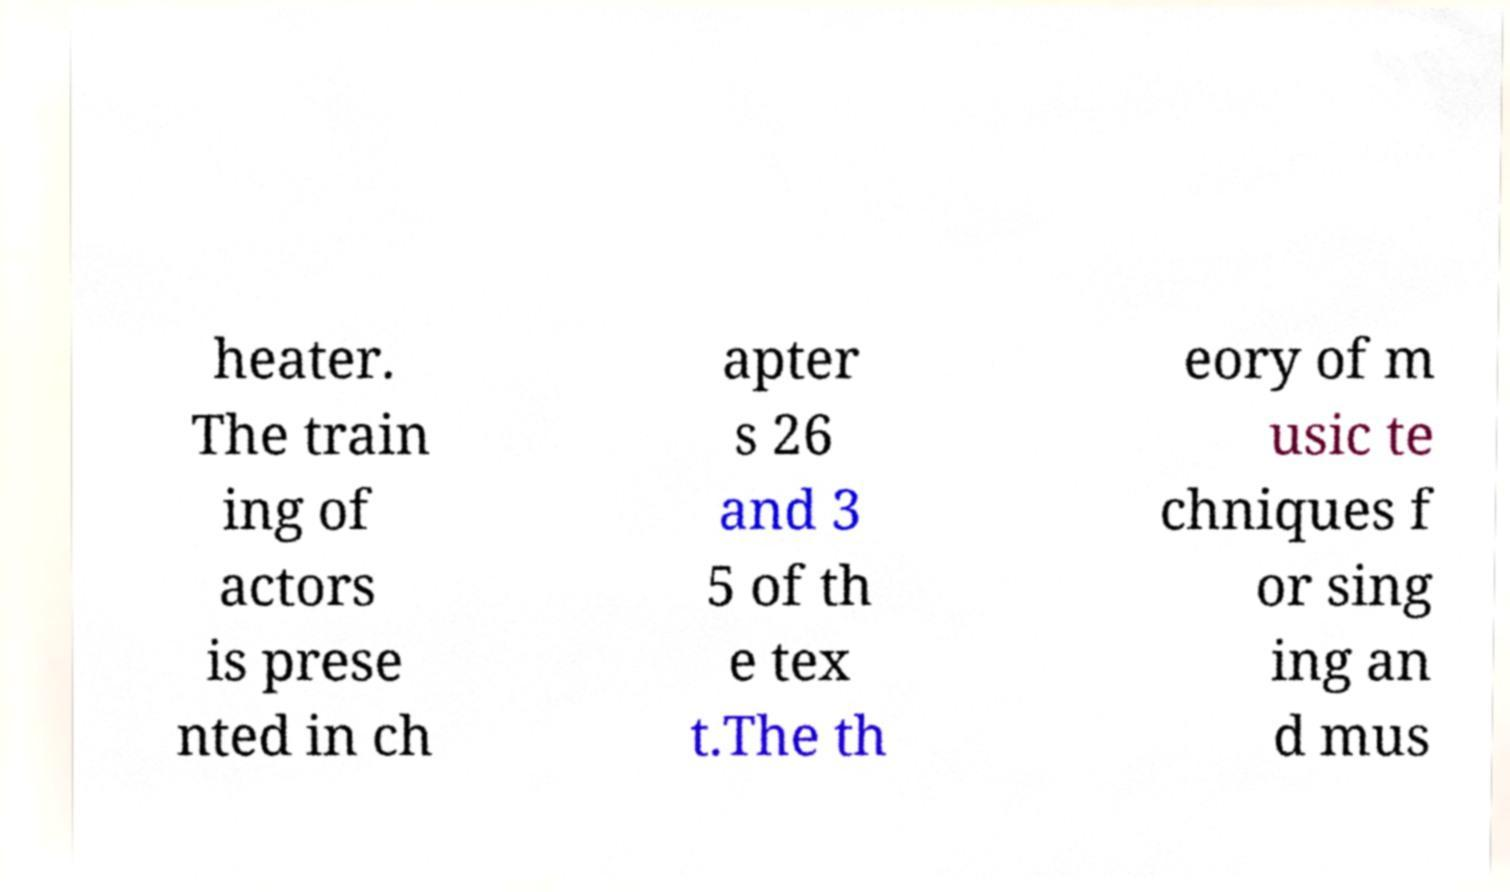Could you extract and type out the text from this image? heater. The train ing of actors is prese nted in ch apter s 26 and 3 5 of th e tex t.The th eory of m usic te chniques f or sing ing an d mus 